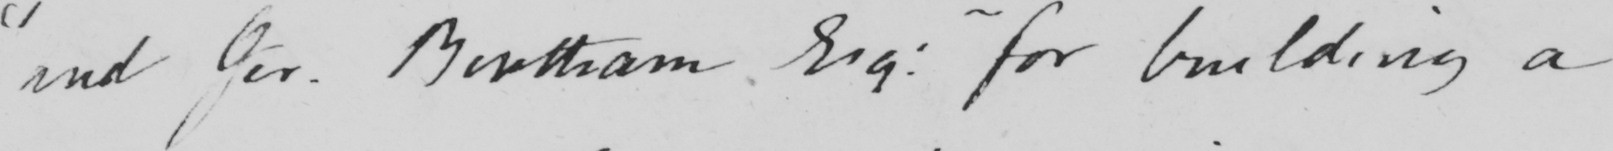Please transcribe the handwritten text in this image. " and Jer . Bentham Esq :  for building a 